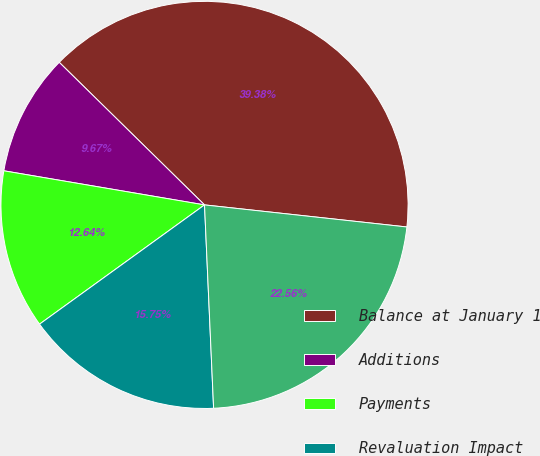Convert chart to OTSL. <chart><loc_0><loc_0><loc_500><loc_500><pie_chart><fcel>Balance at January 1<fcel>Additions<fcel>Payments<fcel>Revaluation Impact<fcel>Balance at December 31<nl><fcel>39.38%<fcel>9.67%<fcel>12.64%<fcel>15.75%<fcel>22.56%<nl></chart> 